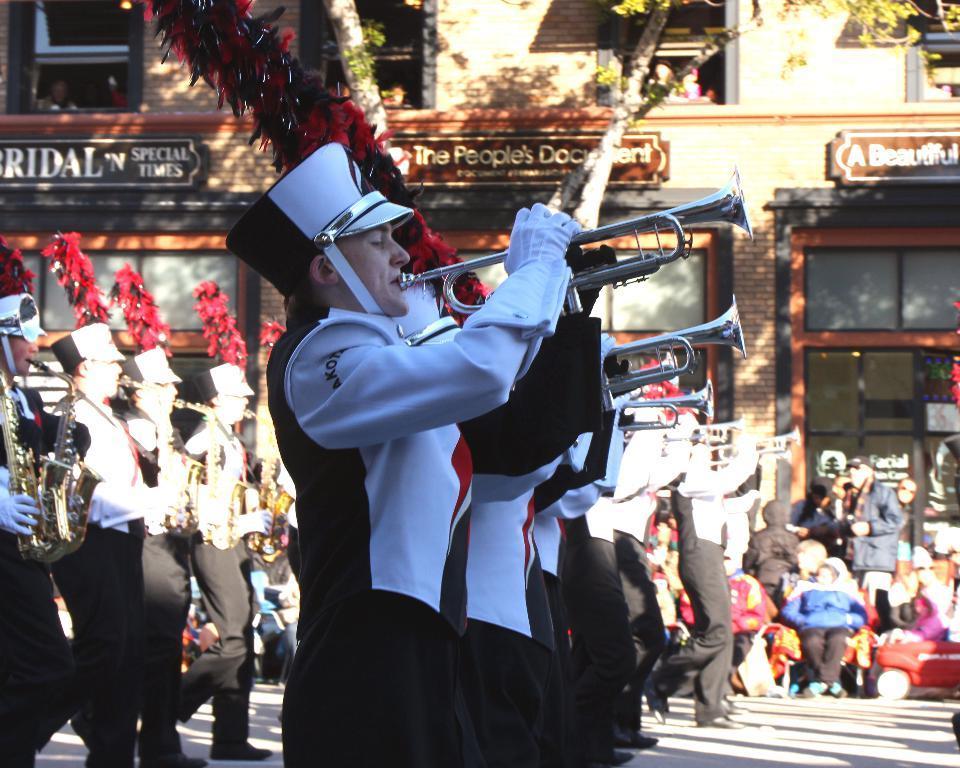In one or two sentences, can you explain what this image depicts? In this picture there are people those who are standing in series, they are playing trumpet and there are other people and a building in the background area of the image, there are windows at the top side of the image, there is a tree in the background area of the image. 